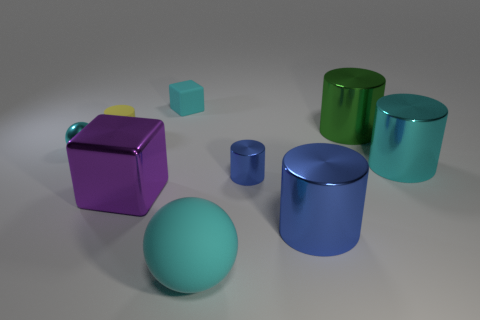Can you describe the colors and shapes of the objects in the image? Certainly! In the image, there are various geometric objects in multiple colors: a large green metallic sphere, a large purple matte cube, a small yellow matte cube, a small teal matte cube, a large cyan metallic cylinder, and a smaller blue metallic cylinder. 